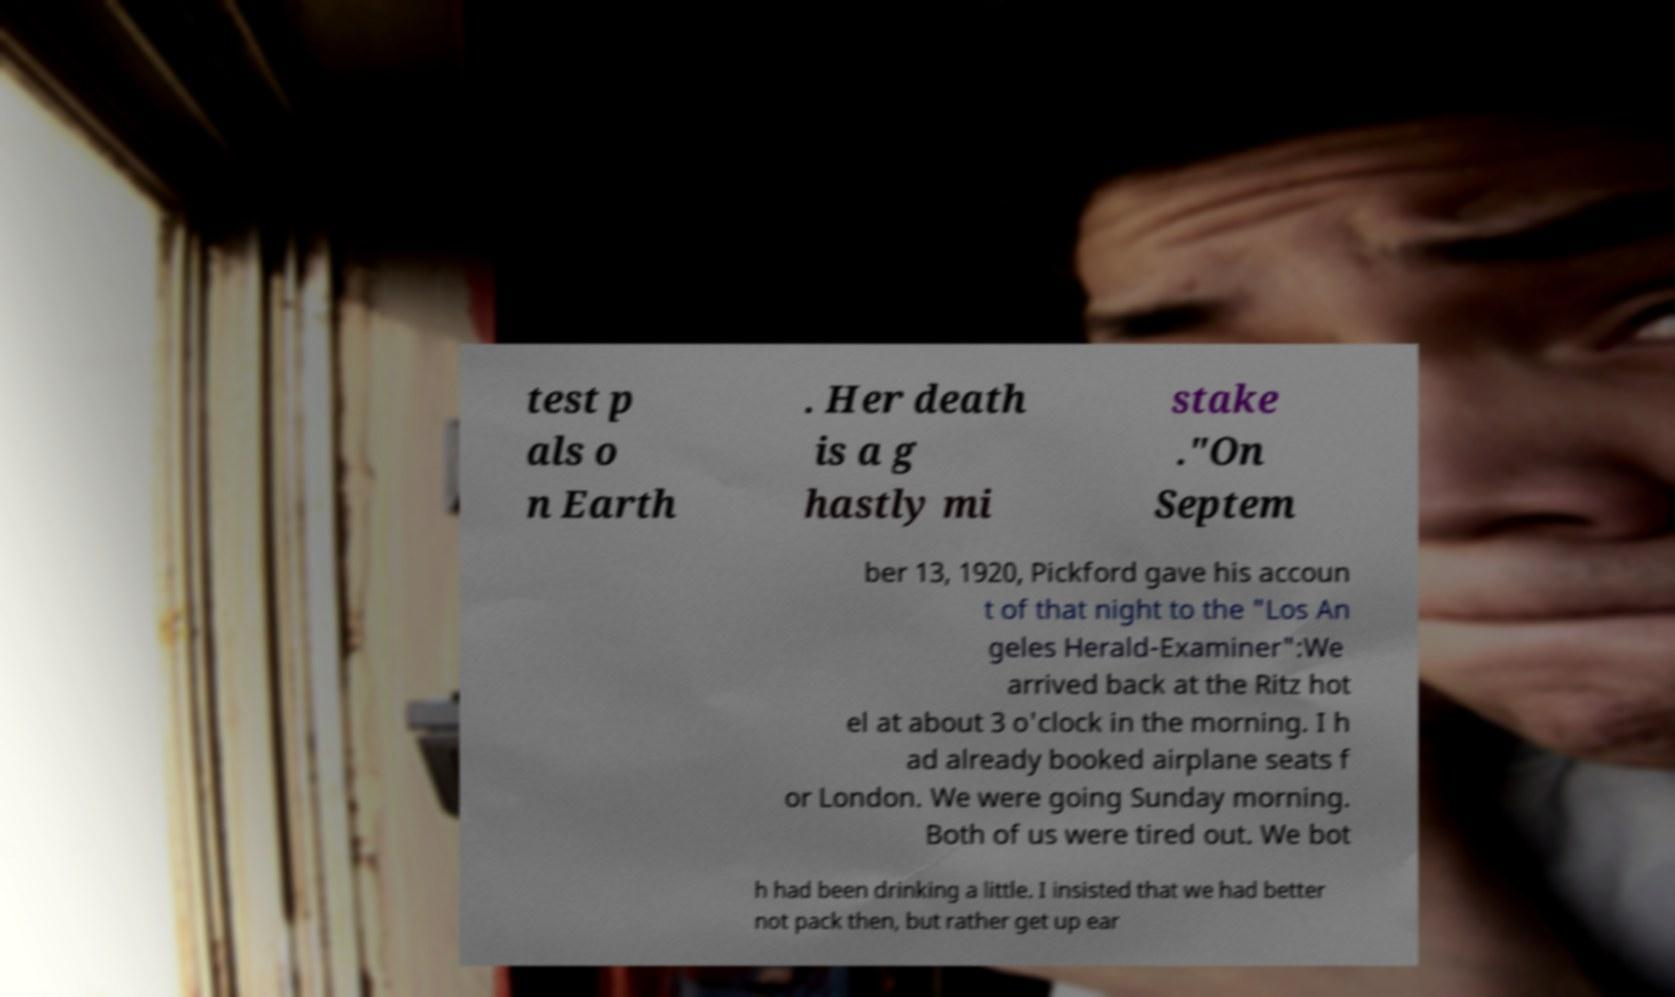Could you assist in decoding the text presented in this image and type it out clearly? test p als o n Earth . Her death is a g hastly mi stake ."On Septem ber 13, 1920, Pickford gave his accoun t of that night to the "Los An geles Herald-Examiner":We arrived back at the Ritz hot el at about 3 o'clock in the morning. I h ad already booked airplane seats f or London. We were going Sunday morning. Both of us were tired out. We bot h had been drinking a little. I insisted that we had better not pack then, but rather get up ear 